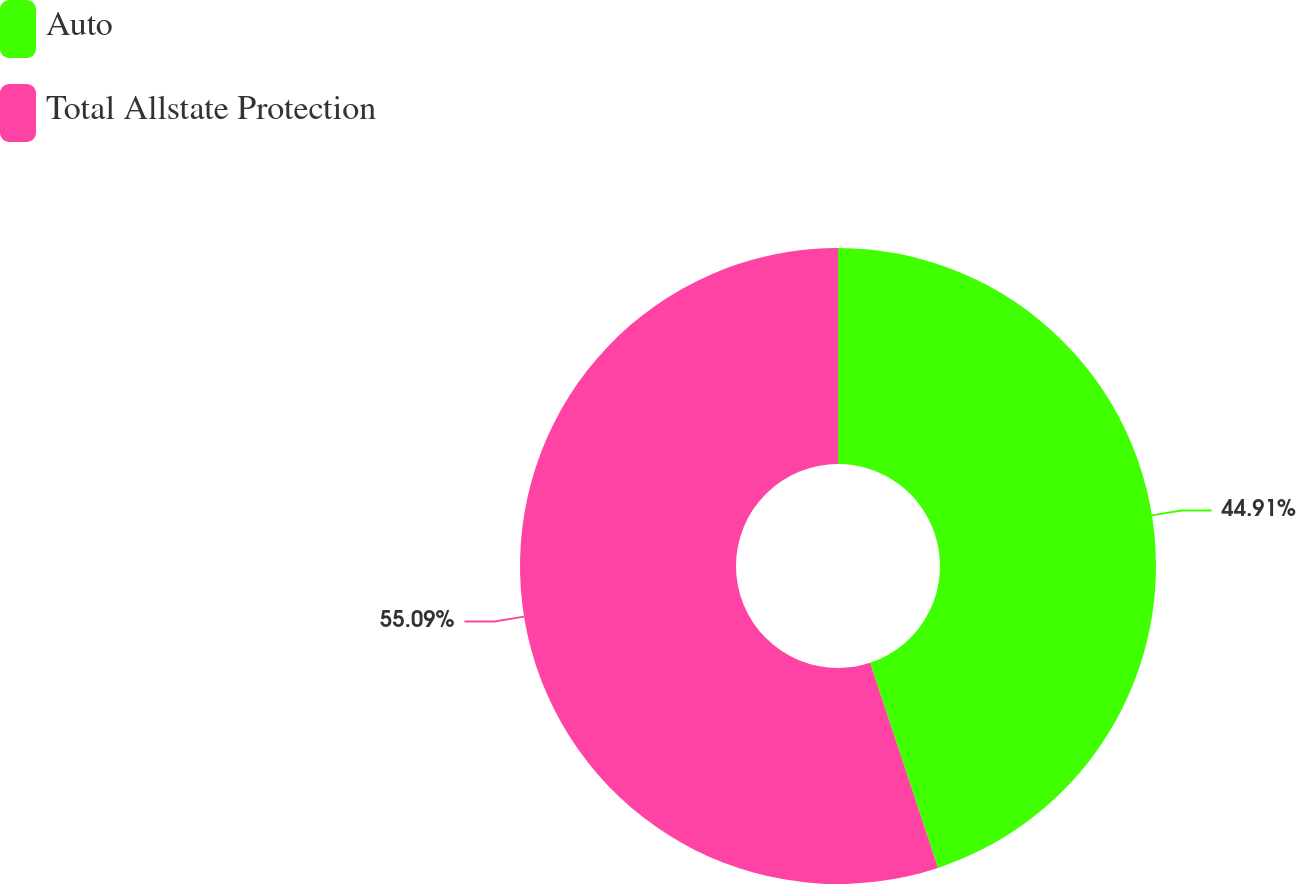Convert chart to OTSL. <chart><loc_0><loc_0><loc_500><loc_500><pie_chart><fcel>Auto<fcel>Total Allstate Protection<nl><fcel>44.91%<fcel>55.09%<nl></chart> 